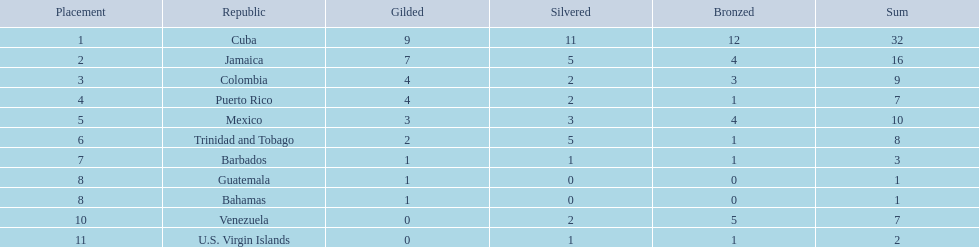Which nations played in the games? Cuba, Jamaica, Colombia, Puerto Rico, Mexico, Trinidad and Tobago, Barbados, Guatemala, Bahamas, Venezuela, U.S. Virgin Islands. How many silver medals did they win? 11, 5, 2, 2, 3, 5, 1, 0, 0, 2, 1. Which team won the most silver? Cuba. 